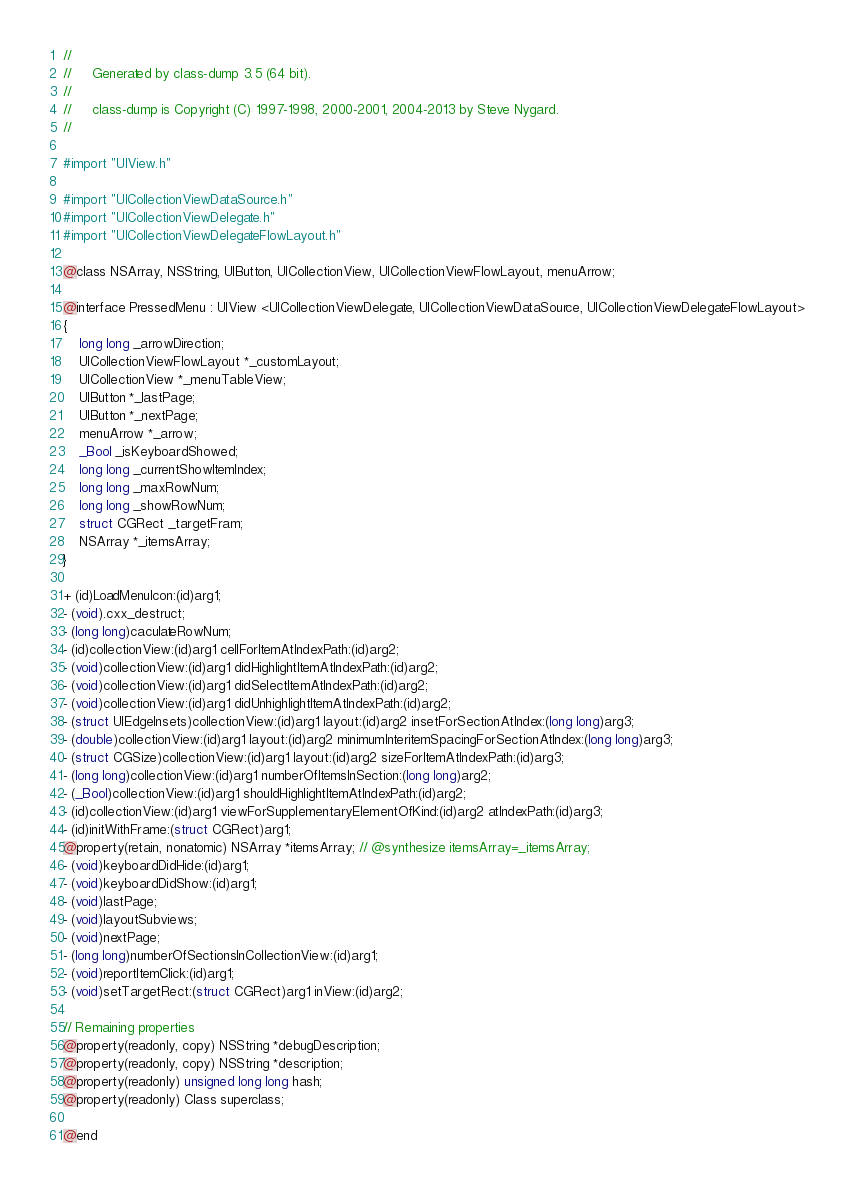Convert code to text. <code><loc_0><loc_0><loc_500><loc_500><_C_>//
//     Generated by class-dump 3.5 (64 bit).
//
//     class-dump is Copyright (C) 1997-1998, 2000-2001, 2004-2013 by Steve Nygard.
//

#import "UIView.h"

#import "UICollectionViewDataSource.h"
#import "UICollectionViewDelegate.h"
#import "UICollectionViewDelegateFlowLayout.h"

@class NSArray, NSString, UIButton, UICollectionView, UICollectionViewFlowLayout, menuArrow;

@interface PressedMenu : UIView <UICollectionViewDelegate, UICollectionViewDataSource, UICollectionViewDelegateFlowLayout>
{
    long long _arrowDirection;
    UICollectionViewFlowLayout *_customLayout;
    UICollectionView *_menuTableView;
    UIButton *_lastPage;
    UIButton *_nextPage;
    menuArrow *_arrow;
    _Bool _isKeyboardShowed;
    long long _currentShowItemIndex;
    long long _maxRowNum;
    long long _showRowNum;
    struct CGRect _targetFram;
    NSArray *_itemsArray;
}

+ (id)LoadMenuIcon:(id)arg1;
- (void).cxx_destruct;
- (long long)caculateRowNum;
- (id)collectionView:(id)arg1 cellForItemAtIndexPath:(id)arg2;
- (void)collectionView:(id)arg1 didHighlightItemAtIndexPath:(id)arg2;
- (void)collectionView:(id)arg1 didSelectItemAtIndexPath:(id)arg2;
- (void)collectionView:(id)arg1 didUnhighlightItemAtIndexPath:(id)arg2;
- (struct UIEdgeInsets)collectionView:(id)arg1 layout:(id)arg2 insetForSectionAtIndex:(long long)arg3;
- (double)collectionView:(id)arg1 layout:(id)arg2 minimumInteritemSpacingForSectionAtIndex:(long long)arg3;
- (struct CGSize)collectionView:(id)arg1 layout:(id)arg2 sizeForItemAtIndexPath:(id)arg3;
- (long long)collectionView:(id)arg1 numberOfItemsInSection:(long long)arg2;
- (_Bool)collectionView:(id)arg1 shouldHighlightItemAtIndexPath:(id)arg2;
- (id)collectionView:(id)arg1 viewForSupplementaryElementOfKind:(id)arg2 atIndexPath:(id)arg3;
- (id)initWithFrame:(struct CGRect)arg1;
@property(retain, nonatomic) NSArray *itemsArray; // @synthesize itemsArray=_itemsArray;
- (void)keyboardDidHide:(id)arg1;
- (void)keyboardDidShow:(id)arg1;
- (void)lastPage;
- (void)layoutSubviews;
- (void)nextPage;
- (long long)numberOfSectionsInCollectionView:(id)arg1;
- (void)reportItemClick:(id)arg1;
- (void)setTargetRect:(struct CGRect)arg1 inView:(id)arg2;

// Remaining properties
@property(readonly, copy) NSString *debugDescription;
@property(readonly, copy) NSString *description;
@property(readonly) unsigned long long hash;
@property(readonly) Class superclass;

@end

</code> 